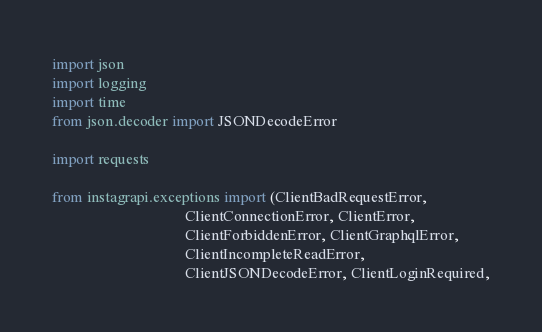Convert code to text. <code><loc_0><loc_0><loc_500><loc_500><_Python_>import json
import logging
import time
from json.decoder import JSONDecodeError

import requests

from instagrapi.exceptions import (ClientBadRequestError,
                                   ClientConnectionError, ClientError,
                                   ClientForbiddenError, ClientGraphqlError,
                                   ClientIncompleteReadError,
                                   ClientJSONDecodeError, ClientLoginRequired,</code> 